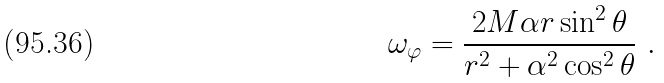<formula> <loc_0><loc_0><loc_500><loc_500>\omega _ { \varphi } = \frac { 2 M \alpha r \sin ^ { 2 } \theta } { r ^ { 2 } + \alpha ^ { 2 } \cos ^ { 2 } \theta } \ .</formula> 